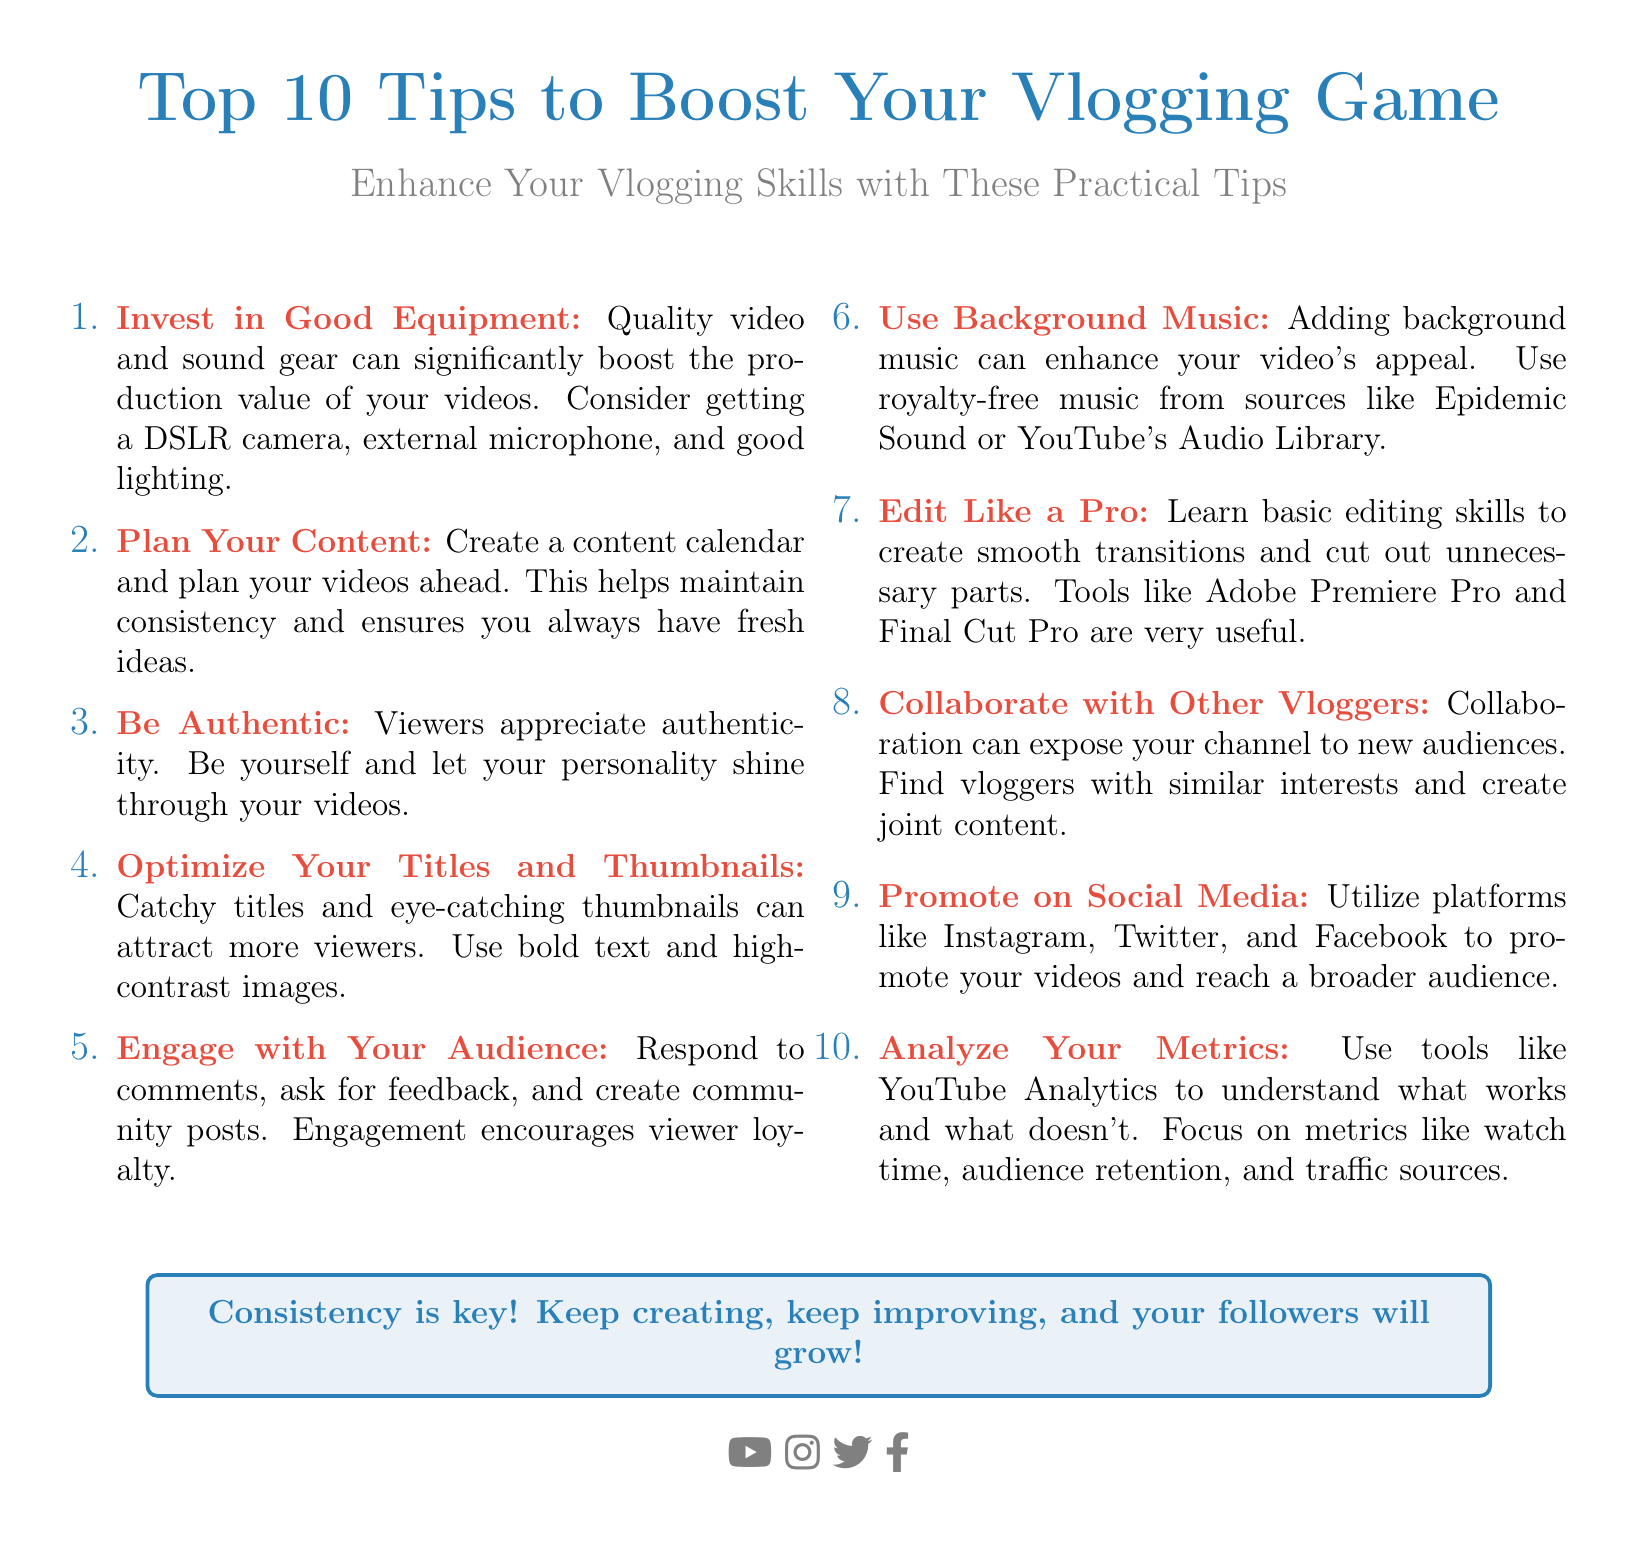What is the title of the flyer? The title summarizes the main topic of the flyer, which focuses on vlogging tips.
Answer: Top 10 Tips to Boost Your Vlogging Game How many tips are listed in the document? The document explicitly states the number of tips included.
Answer: 10 What color is used for the main headings? The color used for emphasis in the headings is specifically defined in the document.
Answer: Main color What is the first tip for boosting vlogging? The document lists tips in a specific order, starting with the first one.
Answer: Invest in Good Equipment Which platform is NOT mentioned for promotion? The question requires recalling platforms from the document that are used for video promotion.
Answer: None What is highlighted as essential for growing followers? This statement sums up the overall advice provided in the conclusion of the flyer.
Answer: Consistency What type of music should be added to videos? The specific type of music that enhances the appeal of videos is identified in the flyer.
Answer: Background music What tool is suggested for editing videos? The document recommends several tools for improving video editing skills.
Answer: Adobe Premiere Pro How can vloggers engage with their audience? This question focuses on the strategies listed in the flyer for audience interaction.
Answer: Respond to comments Which color indicates the tips in the document? This question pertains to the color coding used for the items in the flyer.
Answer: Second color 